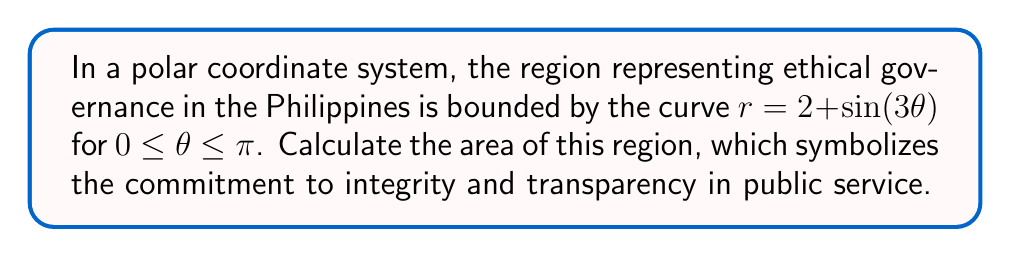Give your solution to this math problem. To calculate the area of the region in polar coordinates, we use the formula:

$$ A = \frac{1}{2} \int_a^b [r(\theta)]^2 d\theta $$

Where $r(\theta) = 2 + \sin(3\theta)$, $a = 0$, and $b = \pi$.

Step 1: Square the given function:
$$ [r(\theta)]^2 = (2 + \sin(3\theta))^2 = 4 + 4\sin(3\theta) + \sin^2(3\theta) $$

Step 2: Set up the integral:
$$ A = \frac{1}{2} \int_0^\pi (4 + 4\sin(3\theta) + \sin^2(3\theta)) d\theta $$

Step 3: Integrate each term:

1) $\int_0^\pi 4 d\theta = 4\theta \big|_0^\pi = 4\pi$

2) $\int_0^\pi 4\sin(3\theta) d\theta = -\frac{4}{3}\cos(3\theta) \big|_0^\pi = -\frac{4}{3}(-1 - 1) = \frac{8}{3}$

3) For $\int_0^\pi \sin^2(3\theta) d\theta$, we use the identity $\sin^2 x = \frac{1 - \cos(2x)}{2}$:
   $\int_0^\pi \sin^2(3\theta) d\theta = \int_0^\pi \frac{1 - \cos(6\theta)}{2} d\theta$
   $= \frac{1}{2}\theta - \frac{1}{12}\sin(6\theta) \big|_0^\pi = \frac{\pi}{2} - 0 = \frac{\pi}{2}$

Step 4: Sum up all parts and multiply by $\frac{1}{2}$:

$$ A = \frac{1}{2} \left(4\pi + \frac{8}{3} + \frac{\pi}{2}\right) = 2\pi + \frac{4}{3} + \frac{\pi}{4} $$

Step 5: Simplify the expression:

$$ A = \frac{9\pi}{4} + \frac{4}{3} \approx 7.85 \text{ square units} $$

This area represents the extent of ethical governance, where a larger area symbolizes a stronger commitment to integrity and transparency in public service.
Answer: $$ A = \frac{9\pi}{4} + \frac{4}{3} \approx 7.85 \text{ square units} $$ 